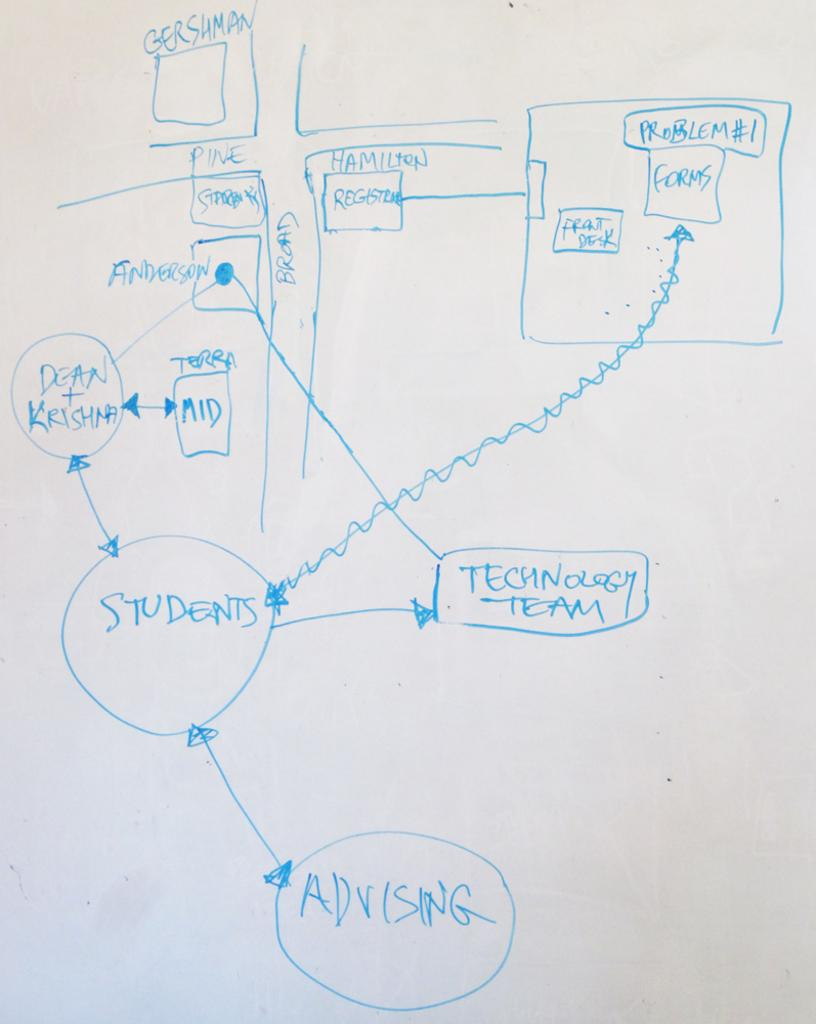<image>
Share a concise interpretation of the image provided. A diagram is displayed with "students" written in a circle. 